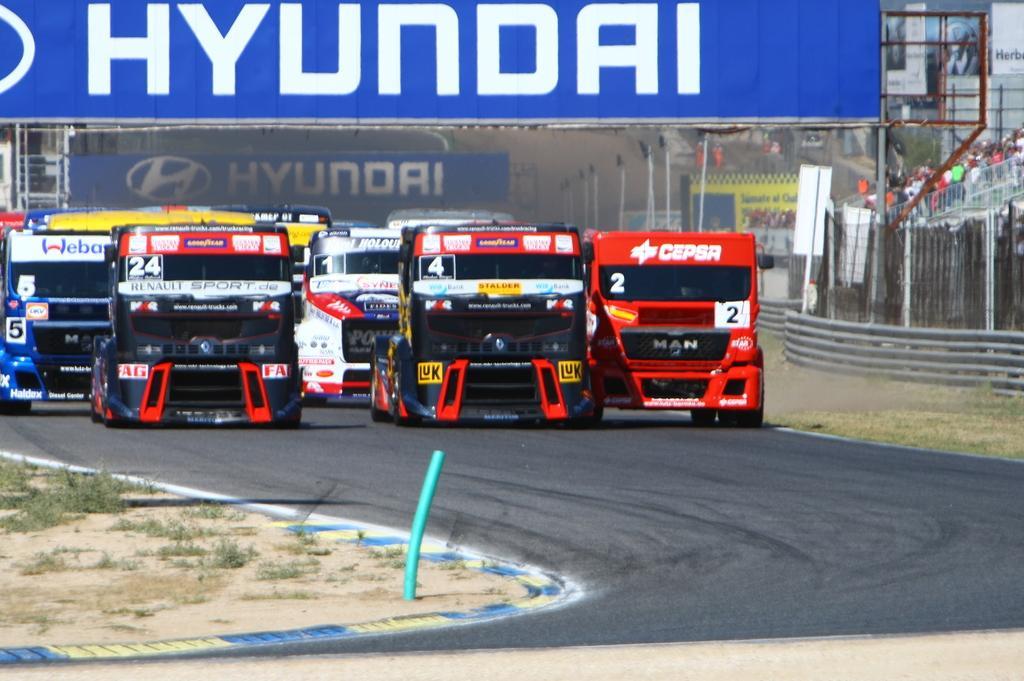Describe this image in one or two sentences. In this image we can see few vehicles on the road, we can see the grass, on the right we can see few people, metal fence, at the top we can see some written text on the board. 